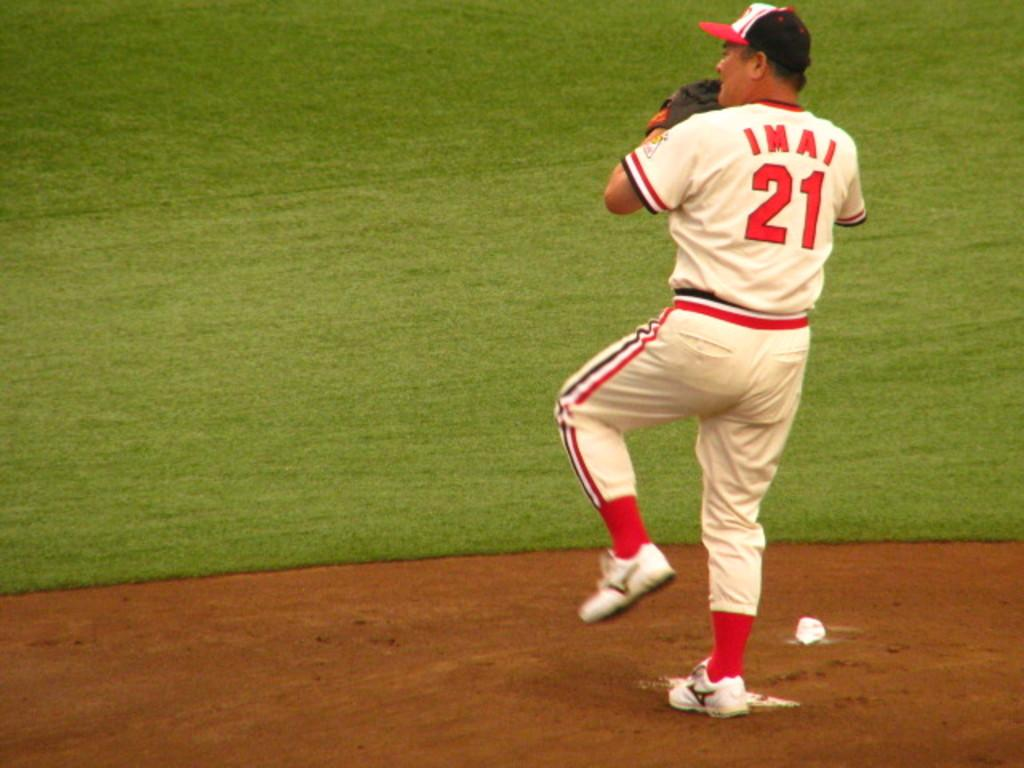<image>
Describe the image concisely. a pitcher on the mound with a jersey number of 21 and his name is IMAI 